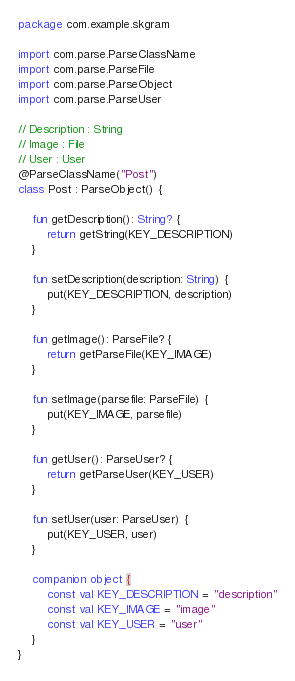Convert code to text. <code><loc_0><loc_0><loc_500><loc_500><_Kotlin_>package com.example.skgram

import com.parse.ParseClassName
import com.parse.ParseFile
import com.parse.ParseObject
import com.parse.ParseUser

// Description : String
// Image : File
// User : User
@ParseClassName("Post")
class Post : ParseObject() {

    fun getDescription(): String? {
        return getString(KEY_DESCRIPTION)
    }

    fun setDescription(description: String) {
        put(KEY_DESCRIPTION, description)
    }

    fun getImage(): ParseFile? {
        return getParseFile(KEY_IMAGE)
    }

    fun setImage(parsefile: ParseFile) {
        put(KEY_IMAGE, parsefile)
    }

    fun getUser(): ParseUser? {
        return getParseUser(KEY_USER)
    }

    fun setUser(user: ParseUser) {
        put(KEY_USER, user)
    }

    companion object {
        const val KEY_DESCRIPTION = "description"
        const val KEY_IMAGE = "image"
        const val KEY_USER = "user"
    }
}</code> 